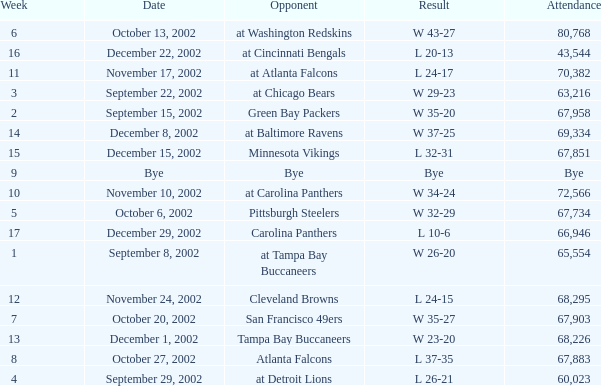Which team was the adversary in the game attended by 65,554? At tampa bay buccaneers. 